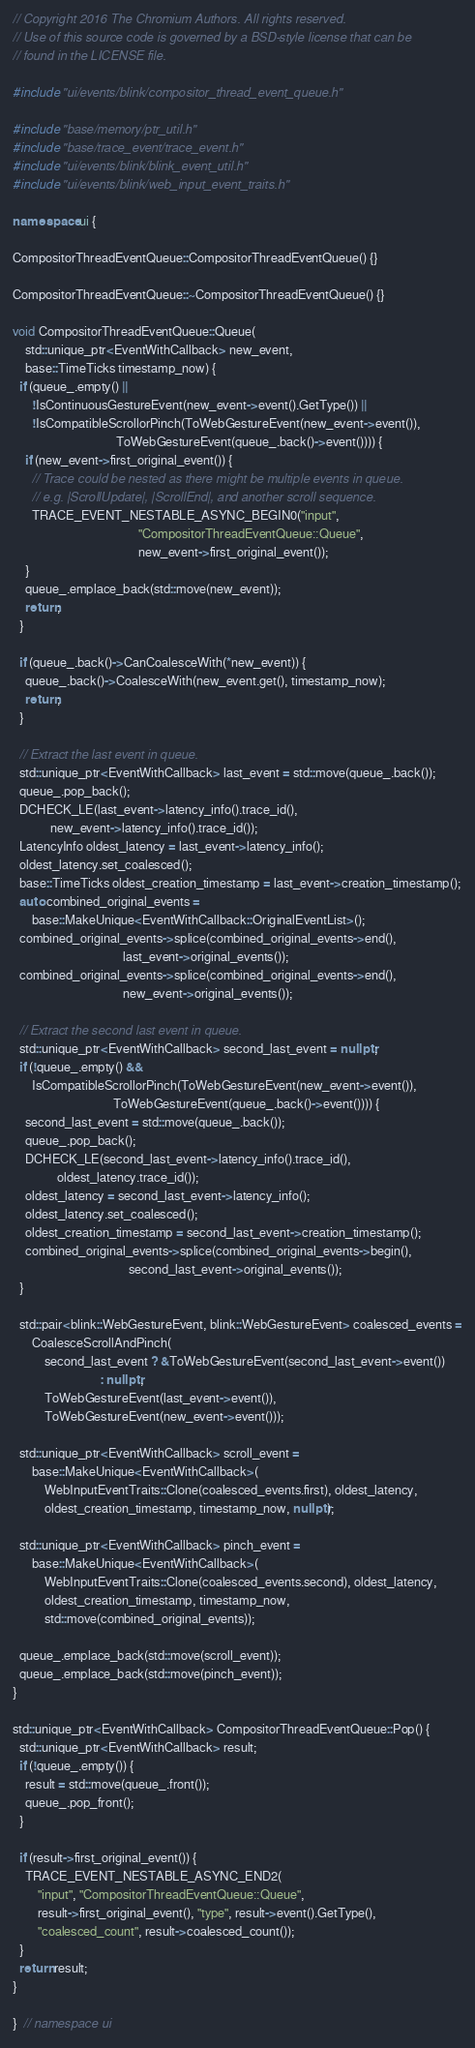<code> <loc_0><loc_0><loc_500><loc_500><_C++_>// Copyright 2016 The Chromium Authors. All rights reserved.
// Use of this source code is governed by a BSD-style license that can be
// found in the LICENSE file.

#include "ui/events/blink/compositor_thread_event_queue.h"

#include "base/memory/ptr_util.h"
#include "base/trace_event/trace_event.h"
#include "ui/events/blink/blink_event_util.h"
#include "ui/events/blink/web_input_event_traits.h"

namespace ui {

CompositorThreadEventQueue::CompositorThreadEventQueue() {}

CompositorThreadEventQueue::~CompositorThreadEventQueue() {}

void CompositorThreadEventQueue::Queue(
    std::unique_ptr<EventWithCallback> new_event,
    base::TimeTicks timestamp_now) {
  if (queue_.empty() ||
      !IsContinuousGestureEvent(new_event->event().GetType()) ||
      !IsCompatibleScrollorPinch(ToWebGestureEvent(new_event->event()),
                                 ToWebGestureEvent(queue_.back()->event()))) {
    if (new_event->first_original_event()) {
      // Trace could be nested as there might be multiple events in queue.
      // e.g. |ScrollUpdate|, |ScrollEnd|, and another scroll sequence.
      TRACE_EVENT_NESTABLE_ASYNC_BEGIN0("input",
                                        "CompositorThreadEventQueue::Queue",
                                        new_event->first_original_event());
    }
    queue_.emplace_back(std::move(new_event));
    return;
  }

  if (queue_.back()->CanCoalesceWith(*new_event)) {
    queue_.back()->CoalesceWith(new_event.get(), timestamp_now);
    return;
  }

  // Extract the last event in queue.
  std::unique_ptr<EventWithCallback> last_event = std::move(queue_.back());
  queue_.pop_back();
  DCHECK_LE(last_event->latency_info().trace_id(),
            new_event->latency_info().trace_id());
  LatencyInfo oldest_latency = last_event->latency_info();
  oldest_latency.set_coalesced();
  base::TimeTicks oldest_creation_timestamp = last_event->creation_timestamp();
  auto combined_original_events =
      base::MakeUnique<EventWithCallback::OriginalEventList>();
  combined_original_events->splice(combined_original_events->end(),
                                   last_event->original_events());
  combined_original_events->splice(combined_original_events->end(),
                                   new_event->original_events());

  // Extract the second last event in queue.
  std::unique_ptr<EventWithCallback> second_last_event = nullptr;
  if (!queue_.empty() &&
      IsCompatibleScrollorPinch(ToWebGestureEvent(new_event->event()),
                                ToWebGestureEvent(queue_.back()->event()))) {
    second_last_event = std::move(queue_.back());
    queue_.pop_back();
    DCHECK_LE(second_last_event->latency_info().trace_id(),
              oldest_latency.trace_id());
    oldest_latency = second_last_event->latency_info();
    oldest_latency.set_coalesced();
    oldest_creation_timestamp = second_last_event->creation_timestamp();
    combined_original_events->splice(combined_original_events->begin(),
                                     second_last_event->original_events());
  }

  std::pair<blink::WebGestureEvent, blink::WebGestureEvent> coalesced_events =
      CoalesceScrollAndPinch(
          second_last_event ? &ToWebGestureEvent(second_last_event->event())
                            : nullptr,
          ToWebGestureEvent(last_event->event()),
          ToWebGestureEvent(new_event->event()));

  std::unique_ptr<EventWithCallback> scroll_event =
      base::MakeUnique<EventWithCallback>(
          WebInputEventTraits::Clone(coalesced_events.first), oldest_latency,
          oldest_creation_timestamp, timestamp_now, nullptr);

  std::unique_ptr<EventWithCallback> pinch_event =
      base::MakeUnique<EventWithCallback>(
          WebInputEventTraits::Clone(coalesced_events.second), oldest_latency,
          oldest_creation_timestamp, timestamp_now,
          std::move(combined_original_events));

  queue_.emplace_back(std::move(scroll_event));
  queue_.emplace_back(std::move(pinch_event));
}

std::unique_ptr<EventWithCallback> CompositorThreadEventQueue::Pop() {
  std::unique_ptr<EventWithCallback> result;
  if (!queue_.empty()) {
    result = std::move(queue_.front());
    queue_.pop_front();
  }

  if (result->first_original_event()) {
    TRACE_EVENT_NESTABLE_ASYNC_END2(
        "input", "CompositorThreadEventQueue::Queue",
        result->first_original_event(), "type", result->event().GetType(),
        "coalesced_count", result->coalesced_count());
  }
  return result;
}

}  // namespace ui
</code> 